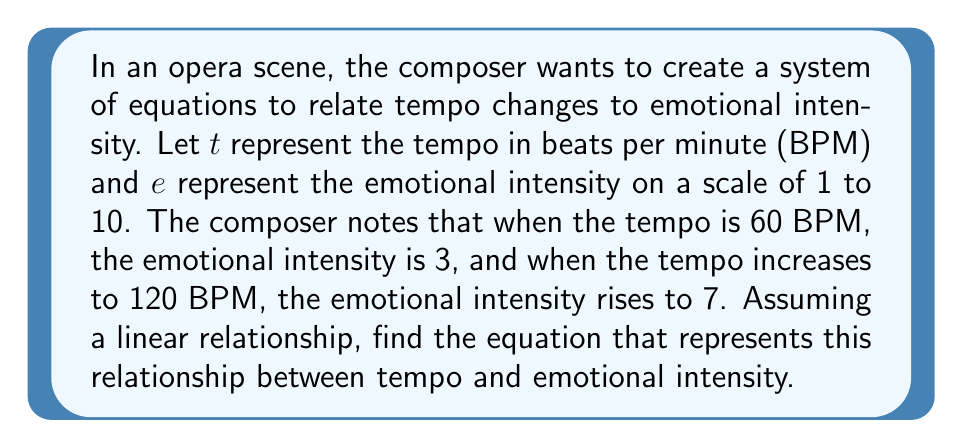Can you solve this math problem? To solve this problem, we'll use a system of linear equations. Let's approach this step-by-step:

1) We're told that the relationship is linear, so we can use the general form of a linear equation:
   $e = mt + b$
   Where $m$ is the slope and $b$ is the y-intercept.

2) We have two points:
   (60, 3) and (120, 7)

3) Let's plug these into our equation:
   3 = 60m + b  (Equation 1)
   7 = 120m + b (Equation 2)

4) Now we have a system of two equations with two unknowns. Let's solve for m by subtracting Equation 1 from Equation 2:
   7 - 3 = (120m + b) - (60m + b)
   4 = 60m

5) Solving for m:
   $m = \frac{4}{60} = \frac{1}{15} = 0.0667$

6) Now that we know m, we can plug it back into either of our original equations to solve for b. Let's use Equation 1:
   3 = 60(0.0667) + b
   3 = 4 + b
   b = -1

7) Now we have both m and b, so we can write our final equation:
   $e = \frac{1}{15}t - 1$

This equation represents the relationship between tempo (t) and emotional intensity (e) in the opera scene.
Answer: $e = \frac{1}{15}t - 1$ 